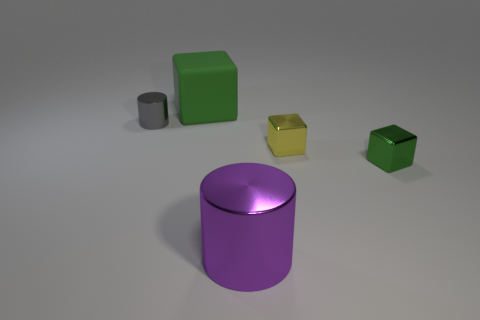Is there any other thing that has the same material as the big green thing?
Your response must be concise. No. What number of green cylinders have the same material as the large purple object?
Your response must be concise. 0. What number of metallic blocks are to the left of the green object that is in front of the matte cube?
Give a very brief answer. 1. What is the shape of the big object that is on the right side of the cube left of the yellow cube that is on the right side of the large shiny thing?
Provide a succinct answer. Cylinder. What number of objects are either yellow objects or brown metallic spheres?
Your answer should be very brief. 1. What color is the thing that is the same size as the purple metal cylinder?
Offer a terse response. Green. Does the tiny green thing have the same shape as the big thing behind the big cylinder?
Offer a very short reply. Yes. What number of things are cylinders that are behind the purple cylinder or big matte things behind the green metal object?
Provide a short and direct response. 2. There is a metal thing that is the same color as the rubber thing; what shape is it?
Your answer should be very brief. Cube. What is the shape of the big object behind the small green metallic object?
Your response must be concise. Cube. 